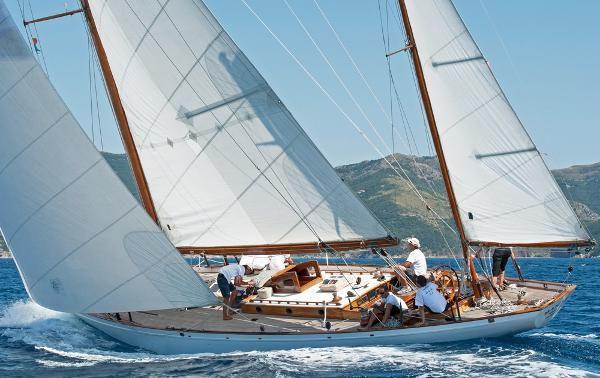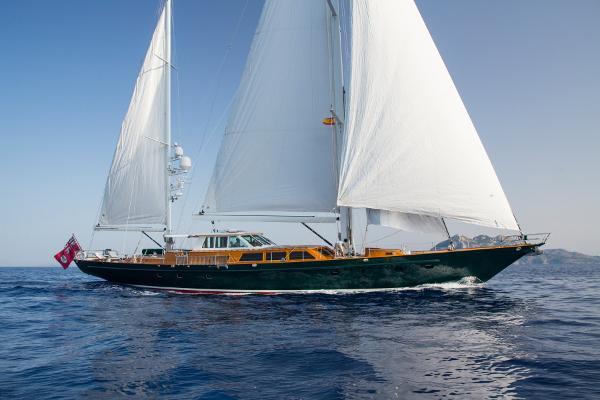The first image is the image on the left, the second image is the image on the right. Evaluate the accuracy of this statement regarding the images: "A sailboat with three white sails is tilted sideways towards the water.". Is it true? Answer yes or no. Yes. 